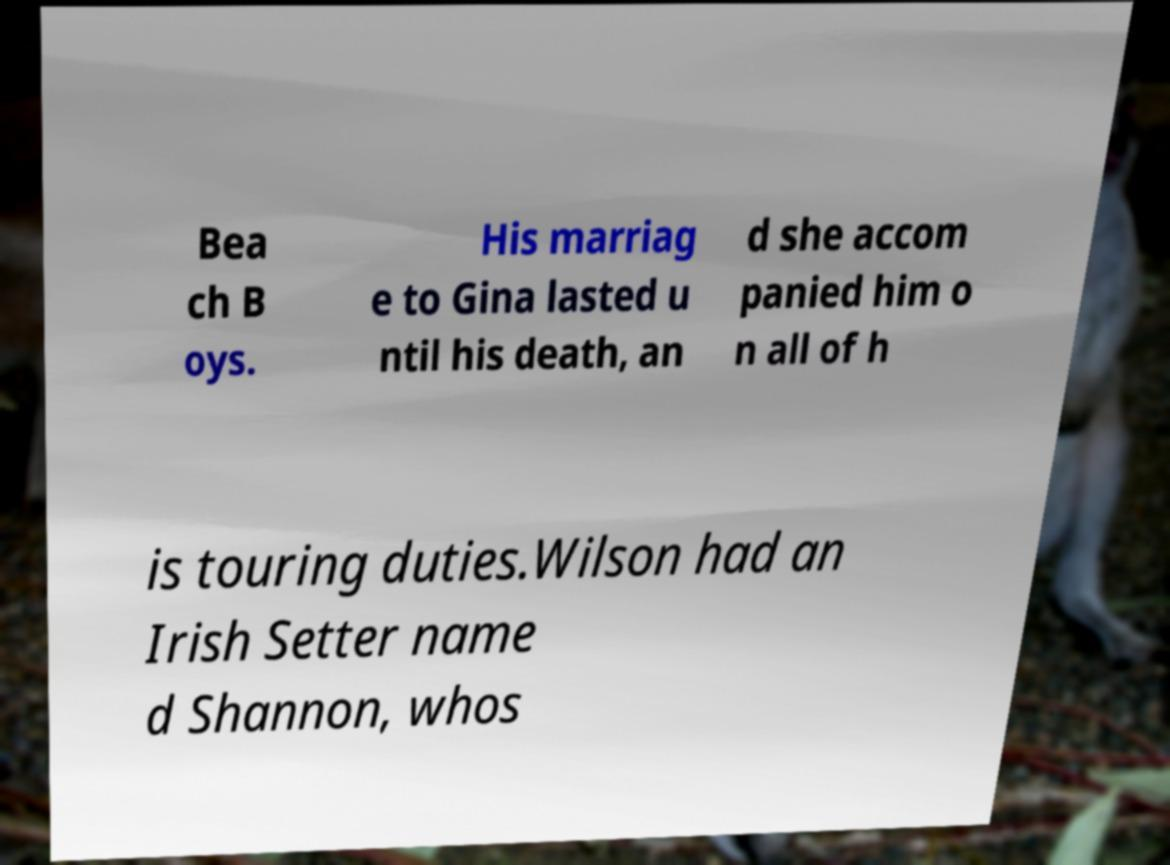There's text embedded in this image that I need extracted. Can you transcribe it verbatim? Bea ch B oys. His marriag e to Gina lasted u ntil his death, an d she accom panied him o n all of h is touring duties.Wilson had an Irish Setter name d Shannon, whos 